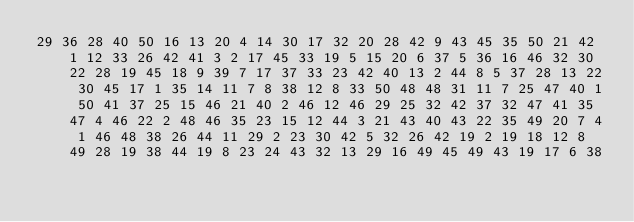<code> <loc_0><loc_0><loc_500><loc_500><_Matlab_>29 36 28 40 50 16 13 20 4 14 30 17 32 20 28 42 9 43 45 35 50 21 42 1 12 33 26 42 41 3 2 17 45 33 19 5 15 20 6 37 5 36 16 46 32 30 22 28 19 45 18 9 39 7 17 37 33 23 42 40 13 2 44 8 5 37 28 13 22 30 45 17 1 35 14 11 7 8 38 12 8 33 50 48 48 31 11 7 25 47 40 1 50 41 37 25 15 46 21 40 2 46 12 46 29 25 32 42 37 32 47 41 35 47 4 46 22 2 48 46 35 23 15 12 44 3 21 43 40 43 22 35 49 20 7 4 1 46 48 38 26 44 11 29 2 23 30 42 5 32 26 42 19 2 19 18 12 8 49 28 19 38 44 19 8 23 24 43 32 13 29 16 49 45 49 43 19 17 6 38</code> 